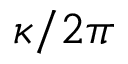Convert formula to latex. <formula><loc_0><loc_0><loc_500><loc_500>\kappa / 2 \pi</formula> 